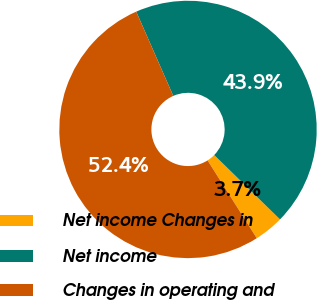<chart> <loc_0><loc_0><loc_500><loc_500><pie_chart><fcel>Net income Changes in<fcel>Net income<fcel>Changes in operating and<nl><fcel>3.71%<fcel>43.91%<fcel>52.38%<nl></chart> 